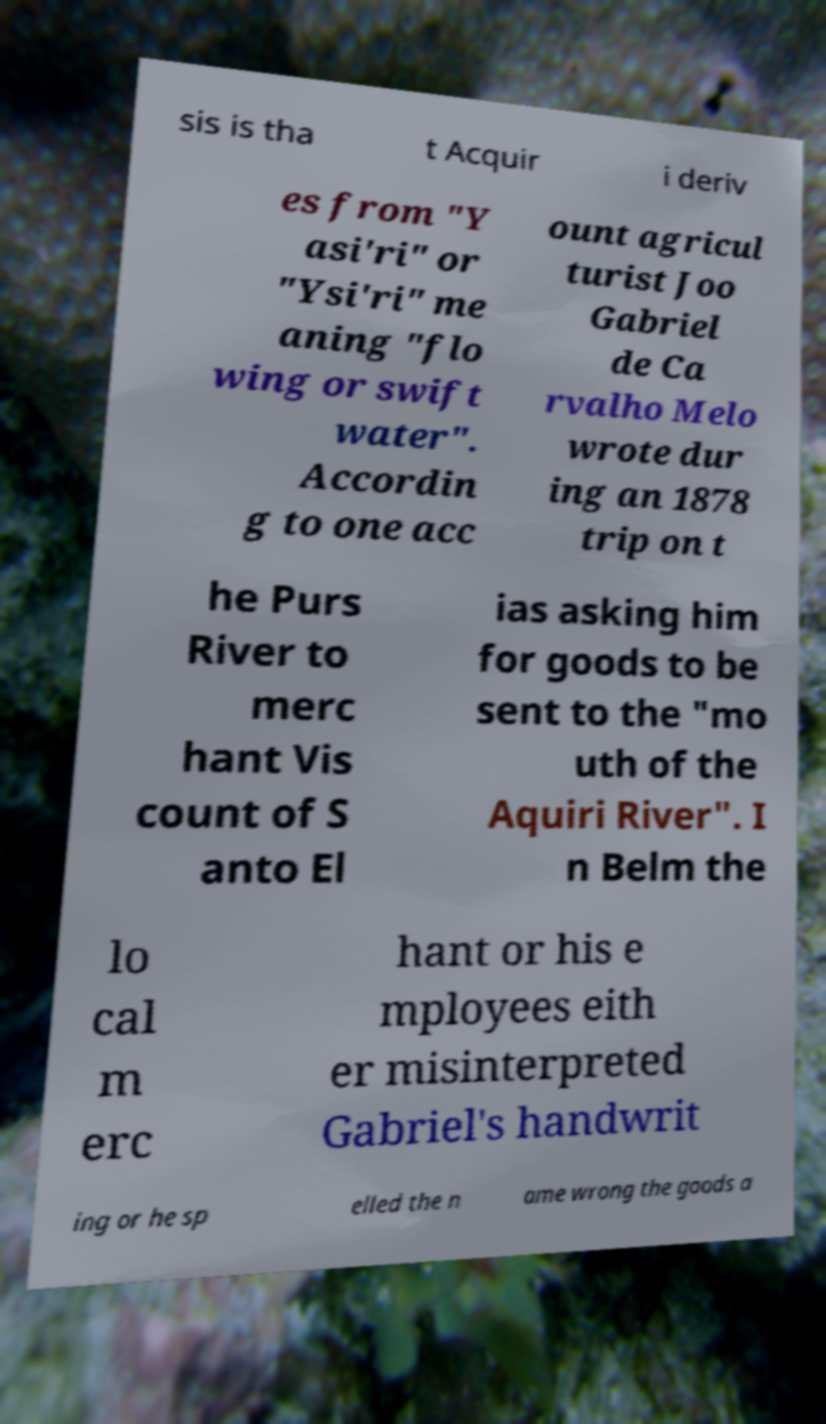What messages or text are displayed in this image? I need them in a readable, typed format. sis is tha t Acquir i deriv es from "Y asi'ri" or "Ysi'ri" me aning "flo wing or swift water". Accordin g to one acc ount agricul turist Joo Gabriel de Ca rvalho Melo wrote dur ing an 1878 trip on t he Purs River to merc hant Vis count of S anto El ias asking him for goods to be sent to the "mo uth of the Aquiri River". I n Belm the lo cal m erc hant or his e mployees eith er misinterpreted Gabriel's handwrit ing or he sp elled the n ame wrong the goods a 